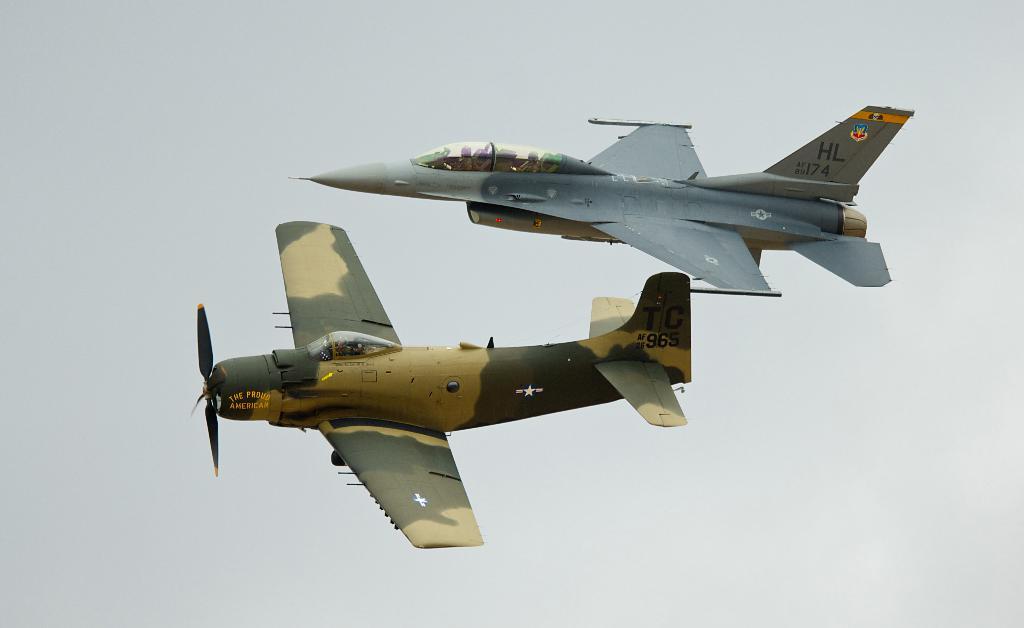Which plane features "hl" on it's body?
Offer a terse response. Top. What is the number on the tail of the camouflaged plane?
Offer a very short reply. 965. 